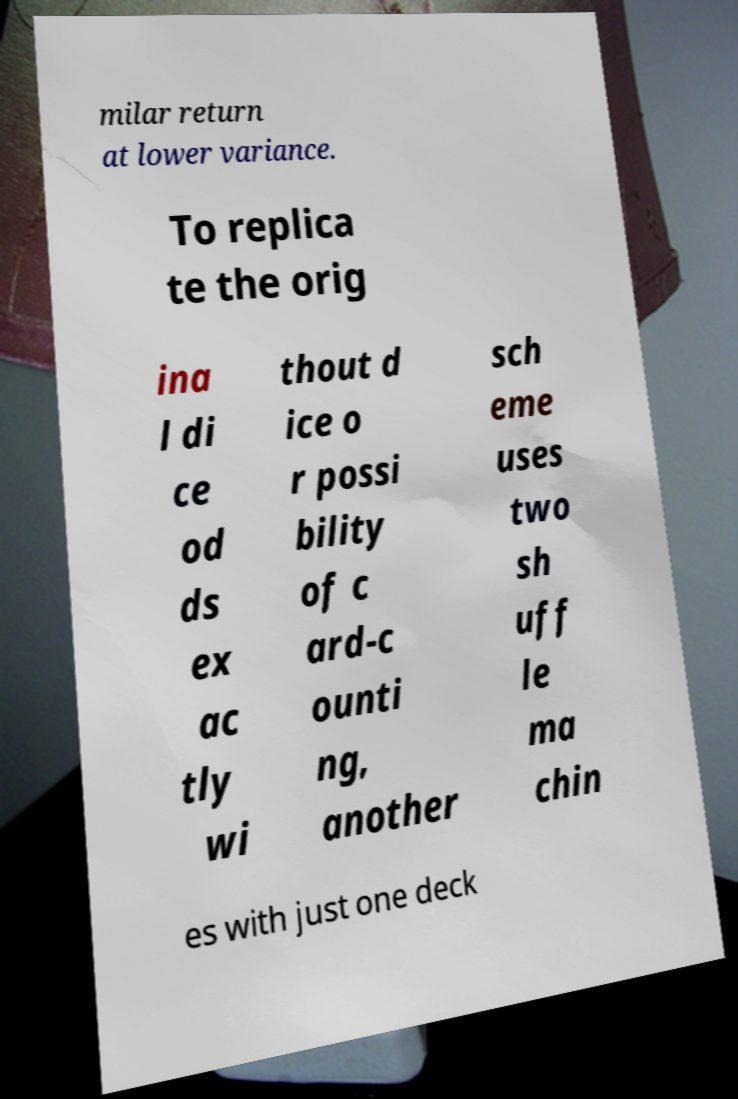Please read and relay the text visible in this image. What does it say? milar return at lower variance. To replica te the orig ina l di ce od ds ex ac tly wi thout d ice o r possi bility of c ard-c ounti ng, another sch eme uses two sh uff le ma chin es with just one deck 